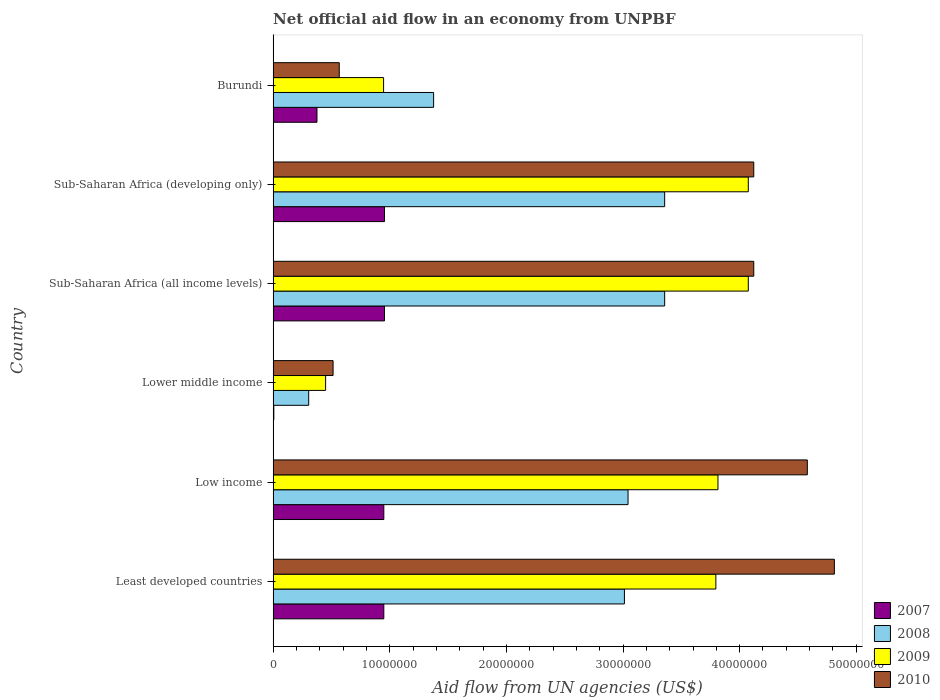How many different coloured bars are there?
Your response must be concise. 4. How many groups of bars are there?
Give a very brief answer. 6. How many bars are there on the 4th tick from the bottom?
Ensure brevity in your answer.  4. What is the net official aid flow in 2007 in Sub-Saharan Africa (developing only)?
Ensure brevity in your answer.  9.55e+06. Across all countries, what is the maximum net official aid flow in 2007?
Offer a very short reply. 9.55e+06. Across all countries, what is the minimum net official aid flow in 2008?
Keep it short and to the point. 3.05e+06. In which country was the net official aid flow in 2010 maximum?
Provide a short and direct response. Least developed countries. In which country was the net official aid flow in 2010 minimum?
Provide a short and direct response. Lower middle income. What is the total net official aid flow in 2008 in the graph?
Provide a succinct answer. 1.44e+08. What is the difference between the net official aid flow in 2007 in Low income and that in Sub-Saharan Africa (developing only)?
Keep it short and to the point. -6.00e+04. What is the difference between the net official aid flow in 2010 in Least developed countries and the net official aid flow in 2007 in Low income?
Your answer should be very brief. 3.86e+07. What is the average net official aid flow in 2009 per country?
Provide a short and direct response. 2.86e+07. What is the difference between the net official aid flow in 2008 and net official aid flow in 2010 in Least developed countries?
Provide a short and direct response. -1.80e+07. In how many countries, is the net official aid flow in 2008 greater than 6000000 US$?
Make the answer very short. 5. What is the ratio of the net official aid flow in 2009 in Least developed countries to that in Low income?
Ensure brevity in your answer.  1. What is the difference between the highest and the second highest net official aid flow in 2010?
Give a very brief answer. 2.32e+06. What is the difference between the highest and the lowest net official aid flow in 2008?
Ensure brevity in your answer.  3.05e+07. Is the sum of the net official aid flow in 2009 in Least developed countries and Sub-Saharan Africa (all income levels) greater than the maximum net official aid flow in 2010 across all countries?
Give a very brief answer. Yes. What does the 3rd bar from the top in Low income represents?
Keep it short and to the point. 2008. How many bars are there?
Give a very brief answer. 24. Are all the bars in the graph horizontal?
Your response must be concise. Yes. What is the difference between two consecutive major ticks on the X-axis?
Offer a terse response. 1.00e+07. How are the legend labels stacked?
Provide a succinct answer. Vertical. What is the title of the graph?
Provide a short and direct response. Net official aid flow in an economy from UNPBF. Does "2015" appear as one of the legend labels in the graph?
Your answer should be compact. No. What is the label or title of the X-axis?
Your answer should be very brief. Aid flow from UN agencies (US$). What is the Aid flow from UN agencies (US$) of 2007 in Least developed countries?
Your answer should be compact. 9.49e+06. What is the Aid flow from UN agencies (US$) of 2008 in Least developed countries?
Your response must be concise. 3.01e+07. What is the Aid flow from UN agencies (US$) of 2009 in Least developed countries?
Make the answer very short. 3.80e+07. What is the Aid flow from UN agencies (US$) in 2010 in Least developed countries?
Your answer should be very brief. 4.81e+07. What is the Aid flow from UN agencies (US$) in 2007 in Low income?
Offer a terse response. 9.49e+06. What is the Aid flow from UN agencies (US$) of 2008 in Low income?
Make the answer very short. 3.04e+07. What is the Aid flow from UN agencies (US$) in 2009 in Low income?
Your answer should be very brief. 3.81e+07. What is the Aid flow from UN agencies (US$) in 2010 in Low income?
Provide a short and direct response. 4.58e+07. What is the Aid flow from UN agencies (US$) of 2007 in Lower middle income?
Your response must be concise. 6.00e+04. What is the Aid flow from UN agencies (US$) in 2008 in Lower middle income?
Your response must be concise. 3.05e+06. What is the Aid flow from UN agencies (US$) of 2009 in Lower middle income?
Your answer should be compact. 4.50e+06. What is the Aid flow from UN agencies (US$) of 2010 in Lower middle income?
Your response must be concise. 5.14e+06. What is the Aid flow from UN agencies (US$) in 2007 in Sub-Saharan Africa (all income levels)?
Keep it short and to the point. 9.55e+06. What is the Aid flow from UN agencies (US$) of 2008 in Sub-Saharan Africa (all income levels)?
Your answer should be compact. 3.36e+07. What is the Aid flow from UN agencies (US$) in 2009 in Sub-Saharan Africa (all income levels)?
Your response must be concise. 4.07e+07. What is the Aid flow from UN agencies (US$) in 2010 in Sub-Saharan Africa (all income levels)?
Your response must be concise. 4.12e+07. What is the Aid flow from UN agencies (US$) in 2007 in Sub-Saharan Africa (developing only)?
Your answer should be compact. 9.55e+06. What is the Aid flow from UN agencies (US$) in 2008 in Sub-Saharan Africa (developing only)?
Provide a succinct answer. 3.36e+07. What is the Aid flow from UN agencies (US$) in 2009 in Sub-Saharan Africa (developing only)?
Offer a terse response. 4.07e+07. What is the Aid flow from UN agencies (US$) in 2010 in Sub-Saharan Africa (developing only)?
Provide a short and direct response. 4.12e+07. What is the Aid flow from UN agencies (US$) of 2007 in Burundi?
Give a very brief answer. 3.76e+06. What is the Aid flow from UN agencies (US$) of 2008 in Burundi?
Keep it short and to the point. 1.38e+07. What is the Aid flow from UN agencies (US$) in 2009 in Burundi?
Keep it short and to the point. 9.47e+06. What is the Aid flow from UN agencies (US$) in 2010 in Burundi?
Offer a terse response. 5.67e+06. Across all countries, what is the maximum Aid flow from UN agencies (US$) of 2007?
Offer a very short reply. 9.55e+06. Across all countries, what is the maximum Aid flow from UN agencies (US$) of 2008?
Give a very brief answer. 3.36e+07. Across all countries, what is the maximum Aid flow from UN agencies (US$) of 2009?
Ensure brevity in your answer.  4.07e+07. Across all countries, what is the maximum Aid flow from UN agencies (US$) in 2010?
Make the answer very short. 4.81e+07. Across all countries, what is the minimum Aid flow from UN agencies (US$) in 2008?
Offer a terse response. 3.05e+06. Across all countries, what is the minimum Aid flow from UN agencies (US$) of 2009?
Provide a succinct answer. 4.50e+06. Across all countries, what is the minimum Aid flow from UN agencies (US$) of 2010?
Make the answer very short. 5.14e+06. What is the total Aid flow from UN agencies (US$) of 2007 in the graph?
Offer a very short reply. 4.19e+07. What is the total Aid flow from UN agencies (US$) of 2008 in the graph?
Give a very brief answer. 1.44e+08. What is the total Aid flow from UN agencies (US$) in 2009 in the graph?
Your response must be concise. 1.72e+08. What is the total Aid flow from UN agencies (US$) in 2010 in the graph?
Offer a terse response. 1.87e+08. What is the difference between the Aid flow from UN agencies (US$) in 2008 in Least developed countries and that in Low income?
Ensure brevity in your answer.  -3.10e+05. What is the difference between the Aid flow from UN agencies (US$) in 2009 in Least developed countries and that in Low income?
Your response must be concise. -1.80e+05. What is the difference between the Aid flow from UN agencies (US$) in 2010 in Least developed countries and that in Low income?
Provide a succinct answer. 2.32e+06. What is the difference between the Aid flow from UN agencies (US$) of 2007 in Least developed countries and that in Lower middle income?
Your answer should be compact. 9.43e+06. What is the difference between the Aid flow from UN agencies (US$) of 2008 in Least developed countries and that in Lower middle income?
Provide a succinct answer. 2.71e+07. What is the difference between the Aid flow from UN agencies (US$) of 2009 in Least developed countries and that in Lower middle income?
Make the answer very short. 3.35e+07. What is the difference between the Aid flow from UN agencies (US$) of 2010 in Least developed countries and that in Lower middle income?
Your response must be concise. 4.30e+07. What is the difference between the Aid flow from UN agencies (US$) in 2008 in Least developed countries and that in Sub-Saharan Africa (all income levels)?
Make the answer very short. -3.45e+06. What is the difference between the Aid flow from UN agencies (US$) in 2009 in Least developed countries and that in Sub-Saharan Africa (all income levels)?
Offer a terse response. -2.78e+06. What is the difference between the Aid flow from UN agencies (US$) of 2010 in Least developed countries and that in Sub-Saharan Africa (all income levels)?
Give a very brief answer. 6.91e+06. What is the difference between the Aid flow from UN agencies (US$) of 2007 in Least developed countries and that in Sub-Saharan Africa (developing only)?
Provide a succinct answer. -6.00e+04. What is the difference between the Aid flow from UN agencies (US$) of 2008 in Least developed countries and that in Sub-Saharan Africa (developing only)?
Offer a terse response. -3.45e+06. What is the difference between the Aid flow from UN agencies (US$) of 2009 in Least developed countries and that in Sub-Saharan Africa (developing only)?
Provide a succinct answer. -2.78e+06. What is the difference between the Aid flow from UN agencies (US$) of 2010 in Least developed countries and that in Sub-Saharan Africa (developing only)?
Provide a succinct answer. 6.91e+06. What is the difference between the Aid flow from UN agencies (US$) in 2007 in Least developed countries and that in Burundi?
Give a very brief answer. 5.73e+06. What is the difference between the Aid flow from UN agencies (US$) in 2008 in Least developed countries and that in Burundi?
Offer a very short reply. 1.64e+07. What is the difference between the Aid flow from UN agencies (US$) in 2009 in Least developed countries and that in Burundi?
Offer a very short reply. 2.85e+07. What is the difference between the Aid flow from UN agencies (US$) in 2010 in Least developed countries and that in Burundi?
Your answer should be compact. 4.24e+07. What is the difference between the Aid flow from UN agencies (US$) in 2007 in Low income and that in Lower middle income?
Your answer should be compact. 9.43e+06. What is the difference between the Aid flow from UN agencies (US$) in 2008 in Low income and that in Lower middle income?
Keep it short and to the point. 2.74e+07. What is the difference between the Aid flow from UN agencies (US$) in 2009 in Low income and that in Lower middle income?
Offer a very short reply. 3.36e+07. What is the difference between the Aid flow from UN agencies (US$) of 2010 in Low income and that in Lower middle income?
Your answer should be very brief. 4.07e+07. What is the difference between the Aid flow from UN agencies (US$) of 2008 in Low income and that in Sub-Saharan Africa (all income levels)?
Your answer should be very brief. -3.14e+06. What is the difference between the Aid flow from UN agencies (US$) of 2009 in Low income and that in Sub-Saharan Africa (all income levels)?
Ensure brevity in your answer.  -2.60e+06. What is the difference between the Aid flow from UN agencies (US$) in 2010 in Low income and that in Sub-Saharan Africa (all income levels)?
Your answer should be very brief. 4.59e+06. What is the difference between the Aid flow from UN agencies (US$) in 2008 in Low income and that in Sub-Saharan Africa (developing only)?
Provide a succinct answer. -3.14e+06. What is the difference between the Aid flow from UN agencies (US$) in 2009 in Low income and that in Sub-Saharan Africa (developing only)?
Make the answer very short. -2.60e+06. What is the difference between the Aid flow from UN agencies (US$) in 2010 in Low income and that in Sub-Saharan Africa (developing only)?
Your response must be concise. 4.59e+06. What is the difference between the Aid flow from UN agencies (US$) in 2007 in Low income and that in Burundi?
Provide a short and direct response. 5.73e+06. What is the difference between the Aid flow from UN agencies (US$) in 2008 in Low income and that in Burundi?
Your answer should be compact. 1.67e+07. What is the difference between the Aid flow from UN agencies (US$) of 2009 in Low income and that in Burundi?
Keep it short and to the point. 2.87e+07. What is the difference between the Aid flow from UN agencies (US$) of 2010 in Low income and that in Burundi?
Your answer should be compact. 4.01e+07. What is the difference between the Aid flow from UN agencies (US$) in 2007 in Lower middle income and that in Sub-Saharan Africa (all income levels)?
Ensure brevity in your answer.  -9.49e+06. What is the difference between the Aid flow from UN agencies (US$) of 2008 in Lower middle income and that in Sub-Saharan Africa (all income levels)?
Offer a very short reply. -3.05e+07. What is the difference between the Aid flow from UN agencies (US$) of 2009 in Lower middle income and that in Sub-Saharan Africa (all income levels)?
Provide a succinct answer. -3.62e+07. What is the difference between the Aid flow from UN agencies (US$) of 2010 in Lower middle income and that in Sub-Saharan Africa (all income levels)?
Ensure brevity in your answer.  -3.61e+07. What is the difference between the Aid flow from UN agencies (US$) in 2007 in Lower middle income and that in Sub-Saharan Africa (developing only)?
Provide a succinct answer. -9.49e+06. What is the difference between the Aid flow from UN agencies (US$) in 2008 in Lower middle income and that in Sub-Saharan Africa (developing only)?
Your answer should be compact. -3.05e+07. What is the difference between the Aid flow from UN agencies (US$) in 2009 in Lower middle income and that in Sub-Saharan Africa (developing only)?
Offer a very short reply. -3.62e+07. What is the difference between the Aid flow from UN agencies (US$) in 2010 in Lower middle income and that in Sub-Saharan Africa (developing only)?
Offer a very short reply. -3.61e+07. What is the difference between the Aid flow from UN agencies (US$) in 2007 in Lower middle income and that in Burundi?
Make the answer very short. -3.70e+06. What is the difference between the Aid flow from UN agencies (US$) in 2008 in Lower middle income and that in Burundi?
Ensure brevity in your answer.  -1.07e+07. What is the difference between the Aid flow from UN agencies (US$) of 2009 in Lower middle income and that in Burundi?
Your answer should be very brief. -4.97e+06. What is the difference between the Aid flow from UN agencies (US$) in 2010 in Lower middle income and that in Burundi?
Keep it short and to the point. -5.30e+05. What is the difference between the Aid flow from UN agencies (US$) in 2007 in Sub-Saharan Africa (all income levels) and that in Sub-Saharan Africa (developing only)?
Provide a short and direct response. 0. What is the difference between the Aid flow from UN agencies (US$) in 2008 in Sub-Saharan Africa (all income levels) and that in Sub-Saharan Africa (developing only)?
Offer a terse response. 0. What is the difference between the Aid flow from UN agencies (US$) of 2007 in Sub-Saharan Africa (all income levels) and that in Burundi?
Provide a succinct answer. 5.79e+06. What is the difference between the Aid flow from UN agencies (US$) of 2008 in Sub-Saharan Africa (all income levels) and that in Burundi?
Your answer should be very brief. 1.98e+07. What is the difference between the Aid flow from UN agencies (US$) of 2009 in Sub-Saharan Africa (all income levels) and that in Burundi?
Offer a terse response. 3.13e+07. What is the difference between the Aid flow from UN agencies (US$) of 2010 in Sub-Saharan Africa (all income levels) and that in Burundi?
Your answer should be compact. 3.55e+07. What is the difference between the Aid flow from UN agencies (US$) of 2007 in Sub-Saharan Africa (developing only) and that in Burundi?
Make the answer very short. 5.79e+06. What is the difference between the Aid flow from UN agencies (US$) of 2008 in Sub-Saharan Africa (developing only) and that in Burundi?
Keep it short and to the point. 1.98e+07. What is the difference between the Aid flow from UN agencies (US$) in 2009 in Sub-Saharan Africa (developing only) and that in Burundi?
Provide a short and direct response. 3.13e+07. What is the difference between the Aid flow from UN agencies (US$) of 2010 in Sub-Saharan Africa (developing only) and that in Burundi?
Offer a terse response. 3.55e+07. What is the difference between the Aid flow from UN agencies (US$) in 2007 in Least developed countries and the Aid flow from UN agencies (US$) in 2008 in Low income?
Provide a short and direct response. -2.09e+07. What is the difference between the Aid flow from UN agencies (US$) of 2007 in Least developed countries and the Aid flow from UN agencies (US$) of 2009 in Low income?
Your response must be concise. -2.86e+07. What is the difference between the Aid flow from UN agencies (US$) in 2007 in Least developed countries and the Aid flow from UN agencies (US$) in 2010 in Low income?
Make the answer very short. -3.63e+07. What is the difference between the Aid flow from UN agencies (US$) of 2008 in Least developed countries and the Aid flow from UN agencies (US$) of 2009 in Low income?
Offer a very short reply. -8.02e+06. What is the difference between the Aid flow from UN agencies (US$) of 2008 in Least developed countries and the Aid flow from UN agencies (US$) of 2010 in Low income?
Ensure brevity in your answer.  -1.57e+07. What is the difference between the Aid flow from UN agencies (US$) of 2009 in Least developed countries and the Aid flow from UN agencies (US$) of 2010 in Low income?
Provide a succinct answer. -7.84e+06. What is the difference between the Aid flow from UN agencies (US$) in 2007 in Least developed countries and the Aid flow from UN agencies (US$) in 2008 in Lower middle income?
Offer a very short reply. 6.44e+06. What is the difference between the Aid flow from UN agencies (US$) in 2007 in Least developed countries and the Aid flow from UN agencies (US$) in 2009 in Lower middle income?
Ensure brevity in your answer.  4.99e+06. What is the difference between the Aid flow from UN agencies (US$) of 2007 in Least developed countries and the Aid flow from UN agencies (US$) of 2010 in Lower middle income?
Offer a terse response. 4.35e+06. What is the difference between the Aid flow from UN agencies (US$) of 2008 in Least developed countries and the Aid flow from UN agencies (US$) of 2009 in Lower middle income?
Give a very brief answer. 2.56e+07. What is the difference between the Aid flow from UN agencies (US$) of 2008 in Least developed countries and the Aid flow from UN agencies (US$) of 2010 in Lower middle income?
Your response must be concise. 2.50e+07. What is the difference between the Aid flow from UN agencies (US$) of 2009 in Least developed countries and the Aid flow from UN agencies (US$) of 2010 in Lower middle income?
Provide a short and direct response. 3.28e+07. What is the difference between the Aid flow from UN agencies (US$) of 2007 in Least developed countries and the Aid flow from UN agencies (US$) of 2008 in Sub-Saharan Africa (all income levels)?
Provide a short and direct response. -2.41e+07. What is the difference between the Aid flow from UN agencies (US$) of 2007 in Least developed countries and the Aid flow from UN agencies (US$) of 2009 in Sub-Saharan Africa (all income levels)?
Keep it short and to the point. -3.12e+07. What is the difference between the Aid flow from UN agencies (US$) of 2007 in Least developed countries and the Aid flow from UN agencies (US$) of 2010 in Sub-Saharan Africa (all income levels)?
Your answer should be very brief. -3.17e+07. What is the difference between the Aid flow from UN agencies (US$) in 2008 in Least developed countries and the Aid flow from UN agencies (US$) in 2009 in Sub-Saharan Africa (all income levels)?
Your answer should be very brief. -1.06e+07. What is the difference between the Aid flow from UN agencies (US$) in 2008 in Least developed countries and the Aid flow from UN agencies (US$) in 2010 in Sub-Saharan Africa (all income levels)?
Your answer should be very brief. -1.11e+07. What is the difference between the Aid flow from UN agencies (US$) in 2009 in Least developed countries and the Aid flow from UN agencies (US$) in 2010 in Sub-Saharan Africa (all income levels)?
Provide a succinct answer. -3.25e+06. What is the difference between the Aid flow from UN agencies (US$) in 2007 in Least developed countries and the Aid flow from UN agencies (US$) in 2008 in Sub-Saharan Africa (developing only)?
Offer a very short reply. -2.41e+07. What is the difference between the Aid flow from UN agencies (US$) of 2007 in Least developed countries and the Aid flow from UN agencies (US$) of 2009 in Sub-Saharan Africa (developing only)?
Make the answer very short. -3.12e+07. What is the difference between the Aid flow from UN agencies (US$) in 2007 in Least developed countries and the Aid flow from UN agencies (US$) in 2010 in Sub-Saharan Africa (developing only)?
Offer a terse response. -3.17e+07. What is the difference between the Aid flow from UN agencies (US$) of 2008 in Least developed countries and the Aid flow from UN agencies (US$) of 2009 in Sub-Saharan Africa (developing only)?
Provide a succinct answer. -1.06e+07. What is the difference between the Aid flow from UN agencies (US$) in 2008 in Least developed countries and the Aid flow from UN agencies (US$) in 2010 in Sub-Saharan Africa (developing only)?
Provide a succinct answer. -1.11e+07. What is the difference between the Aid flow from UN agencies (US$) of 2009 in Least developed countries and the Aid flow from UN agencies (US$) of 2010 in Sub-Saharan Africa (developing only)?
Ensure brevity in your answer.  -3.25e+06. What is the difference between the Aid flow from UN agencies (US$) of 2007 in Least developed countries and the Aid flow from UN agencies (US$) of 2008 in Burundi?
Give a very brief answer. -4.27e+06. What is the difference between the Aid flow from UN agencies (US$) of 2007 in Least developed countries and the Aid flow from UN agencies (US$) of 2009 in Burundi?
Provide a succinct answer. 2.00e+04. What is the difference between the Aid flow from UN agencies (US$) in 2007 in Least developed countries and the Aid flow from UN agencies (US$) in 2010 in Burundi?
Give a very brief answer. 3.82e+06. What is the difference between the Aid flow from UN agencies (US$) in 2008 in Least developed countries and the Aid flow from UN agencies (US$) in 2009 in Burundi?
Ensure brevity in your answer.  2.06e+07. What is the difference between the Aid flow from UN agencies (US$) in 2008 in Least developed countries and the Aid flow from UN agencies (US$) in 2010 in Burundi?
Offer a very short reply. 2.44e+07. What is the difference between the Aid flow from UN agencies (US$) in 2009 in Least developed countries and the Aid flow from UN agencies (US$) in 2010 in Burundi?
Your response must be concise. 3.23e+07. What is the difference between the Aid flow from UN agencies (US$) in 2007 in Low income and the Aid flow from UN agencies (US$) in 2008 in Lower middle income?
Provide a short and direct response. 6.44e+06. What is the difference between the Aid flow from UN agencies (US$) in 2007 in Low income and the Aid flow from UN agencies (US$) in 2009 in Lower middle income?
Your response must be concise. 4.99e+06. What is the difference between the Aid flow from UN agencies (US$) of 2007 in Low income and the Aid flow from UN agencies (US$) of 2010 in Lower middle income?
Offer a very short reply. 4.35e+06. What is the difference between the Aid flow from UN agencies (US$) of 2008 in Low income and the Aid flow from UN agencies (US$) of 2009 in Lower middle income?
Provide a succinct answer. 2.59e+07. What is the difference between the Aid flow from UN agencies (US$) in 2008 in Low income and the Aid flow from UN agencies (US$) in 2010 in Lower middle income?
Keep it short and to the point. 2.53e+07. What is the difference between the Aid flow from UN agencies (US$) of 2009 in Low income and the Aid flow from UN agencies (US$) of 2010 in Lower middle income?
Your response must be concise. 3.30e+07. What is the difference between the Aid flow from UN agencies (US$) in 2007 in Low income and the Aid flow from UN agencies (US$) in 2008 in Sub-Saharan Africa (all income levels)?
Provide a succinct answer. -2.41e+07. What is the difference between the Aid flow from UN agencies (US$) in 2007 in Low income and the Aid flow from UN agencies (US$) in 2009 in Sub-Saharan Africa (all income levels)?
Make the answer very short. -3.12e+07. What is the difference between the Aid flow from UN agencies (US$) of 2007 in Low income and the Aid flow from UN agencies (US$) of 2010 in Sub-Saharan Africa (all income levels)?
Offer a very short reply. -3.17e+07. What is the difference between the Aid flow from UN agencies (US$) in 2008 in Low income and the Aid flow from UN agencies (US$) in 2009 in Sub-Saharan Africa (all income levels)?
Ensure brevity in your answer.  -1.03e+07. What is the difference between the Aid flow from UN agencies (US$) of 2008 in Low income and the Aid flow from UN agencies (US$) of 2010 in Sub-Saharan Africa (all income levels)?
Offer a very short reply. -1.08e+07. What is the difference between the Aid flow from UN agencies (US$) of 2009 in Low income and the Aid flow from UN agencies (US$) of 2010 in Sub-Saharan Africa (all income levels)?
Your response must be concise. -3.07e+06. What is the difference between the Aid flow from UN agencies (US$) of 2007 in Low income and the Aid flow from UN agencies (US$) of 2008 in Sub-Saharan Africa (developing only)?
Keep it short and to the point. -2.41e+07. What is the difference between the Aid flow from UN agencies (US$) of 2007 in Low income and the Aid flow from UN agencies (US$) of 2009 in Sub-Saharan Africa (developing only)?
Keep it short and to the point. -3.12e+07. What is the difference between the Aid flow from UN agencies (US$) in 2007 in Low income and the Aid flow from UN agencies (US$) in 2010 in Sub-Saharan Africa (developing only)?
Your response must be concise. -3.17e+07. What is the difference between the Aid flow from UN agencies (US$) in 2008 in Low income and the Aid flow from UN agencies (US$) in 2009 in Sub-Saharan Africa (developing only)?
Give a very brief answer. -1.03e+07. What is the difference between the Aid flow from UN agencies (US$) of 2008 in Low income and the Aid flow from UN agencies (US$) of 2010 in Sub-Saharan Africa (developing only)?
Keep it short and to the point. -1.08e+07. What is the difference between the Aid flow from UN agencies (US$) of 2009 in Low income and the Aid flow from UN agencies (US$) of 2010 in Sub-Saharan Africa (developing only)?
Keep it short and to the point. -3.07e+06. What is the difference between the Aid flow from UN agencies (US$) in 2007 in Low income and the Aid flow from UN agencies (US$) in 2008 in Burundi?
Give a very brief answer. -4.27e+06. What is the difference between the Aid flow from UN agencies (US$) of 2007 in Low income and the Aid flow from UN agencies (US$) of 2010 in Burundi?
Offer a very short reply. 3.82e+06. What is the difference between the Aid flow from UN agencies (US$) in 2008 in Low income and the Aid flow from UN agencies (US$) in 2009 in Burundi?
Your answer should be compact. 2.10e+07. What is the difference between the Aid flow from UN agencies (US$) of 2008 in Low income and the Aid flow from UN agencies (US$) of 2010 in Burundi?
Your answer should be very brief. 2.48e+07. What is the difference between the Aid flow from UN agencies (US$) in 2009 in Low income and the Aid flow from UN agencies (US$) in 2010 in Burundi?
Provide a succinct answer. 3.25e+07. What is the difference between the Aid flow from UN agencies (US$) in 2007 in Lower middle income and the Aid flow from UN agencies (US$) in 2008 in Sub-Saharan Africa (all income levels)?
Your response must be concise. -3.35e+07. What is the difference between the Aid flow from UN agencies (US$) of 2007 in Lower middle income and the Aid flow from UN agencies (US$) of 2009 in Sub-Saharan Africa (all income levels)?
Your answer should be compact. -4.07e+07. What is the difference between the Aid flow from UN agencies (US$) in 2007 in Lower middle income and the Aid flow from UN agencies (US$) in 2010 in Sub-Saharan Africa (all income levels)?
Your response must be concise. -4.12e+07. What is the difference between the Aid flow from UN agencies (US$) of 2008 in Lower middle income and the Aid flow from UN agencies (US$) of 2009 in Sub-Saharan Africa (all income levels)?
Give a very brief answer. -3.77e+07. What is the difference between the Aid flow from UN agencies (US$) in 2008 in Lower middle income and the Aid flow from UN agencies (US$) in 2010 in Sub-Saharan Africa (all income levels)?
Offer a terse response. -3.82e+07. What is the difference between the Aid flow from UN agencies (US$) of 2009 in Lower middle income and the Aid flow from UN agencies (US$) of 2010 in Sub-Saharan Africa (all income levels)?
Your answer should be compact. -3.67e+07. What is the difference between the Aid flow from UN agencies (US$) of 2007 in Lower middle income and the Aid flow from UN agencies (US$) of 2008 in Sub-Saharan Africa (developing only)?
Your answer should be very brief. -3.35e+07. What is the difference between the Aid flow from UN agencies (US$) of 2007 in Lower middle income and the Aid flow from UN agencies (US$) of 2009 in Sub-Saharan Africa (developing only)?
Keep it short and to the point. -4.07e+07. What is the difference between the Aid flow from UN agencies (US$) in 2007 in Lower middle income and the Aid flow from UN agencies (US$) in 2010 in Sub-Saharan Africa (developing only)?
Ensure brevity in your answer.  -4.12e+07. What is the difference between the Aid flow from UN agencies (US$) of 2008 in Lower middle income and the Aid flow from UN agencies (US$) of 2009 in Sub-Saharan Africa (developing only)?
Keep it short and to the point. -3.77e+07. What is the difference between the Aid flow from UN agencies (US$) in 2008 in Lower middle income and the Aid flow from UN agencies (US$) in 2010 in Sub-Saharan Africa (developing only)?
Keep it short and to the point. -3.82e+07. What is the difference between the Aid flow from UN agencies (US$) of 2009 in Lower middle income and the Aid flow from UN agencies (US$) of 2010 in Sub-Saharan Africa (developing only)?
Your answer should be very brief. -3.67e+07. What is the difference between the Aid flow from UN agencies (US$) of 2007 in Lower middle income and the Aid flow from UN agencies (US$) of 2008 in Burundi?
Keep it short and to the point. -1.37e+07. What is the difference between the Aid flow from UN agencies (US$) of 2007 in Lower middle income and the Aid flow from UN agencies (US$) of 2009 in Burundi?
Keep it short and to the point. -9.41e+06. What is the difference between the Aid flow from UN agencies (US$) in 2007 in Lower middle income and the Aid flow from UN agencies (US$) in 2010 in Burundi?
Your answer should be compact. -5.61e+06. What is the difference between the Aid flow from UN agencies (US$) of 2008 in Lower middle income and the Aid flow from UN agencies (US$) of 2009 in Burundi?
Your response must be concise. -6.42e+06. What is the difference between the Aid flow from UN agencies (US$) in 2008 in Lower middle income and the Aid flow from UN agencies (US$) in 2010 in Burundi?
Give a very brief answer. -2.62e+06. What is the difference between the Aid flow from UN agencies (US$) of 2009 in Lower middle income and the Aid flow from UN agencies (US$) of 2010 in Burundi?
Provide a short and direct response. -1.17e+06. What is the difference between the Aid flow from UN agencies (US$) of 2007 in Sub-Saharan Africa (all income levels) and the Aid flow from UN agencies (US$) of 2008 in Sub-Saharan Africa (developing only)?
Give a very brief answer. -2.40e+07. What is the difference between the Aid flow from UN agencies (US$) of 2007 in Sub-Saharan Africa (all income levels) and the Aid flow from UN agencies (US$) of 2009 in Sub-Saharan Africa (developing only)?
Your answer should be compact. -3.12e+07. What is the difference between the Aid flow from UN agencies (US$) of 2007 in Sub-Saharan Africa (all income levels) and the Aid flow from UN agencies (US$) of 2010 in Sub-Saharan Africa (developing only)?
Offer a very short reply. -3.17e+07. What is the difference between the Aid flow from UN agencies (US$) in 2008 in Sub-Saharan Africa (all income levels) and the Aid flow from UN agencies (US$) in 2009 in Sub-Saharan Africa (developing only)?
Offer a terse response. -7.17e+06. What is the difference between the Aid flow from UN agencies (US$) of 2008 in Sub-Saharan Africa (all income levels) and the Aid flow from UN agencies (US$) of 2010 in Sub-Saharan Africa (developing only)?
Make the answer very short. -7.64e+06. What is the difference between the Aid flow from UN agencies (US$) of 2009 in Sub-Saharan Africa (all income levels) and the Aid flow from UN agencies (US$) of 2010 in Sub-Saharan Africa (developing only)?
Give a very brief answer. -4.70e+05. What is the difference between the Aid flow from UN agencies (US$) in 2007 in Sub-Saharan Africa (all income levels) and the Aid flow from UN agencies (US$) in 2008 in Burundi?
Give a very brief answer. -4.21e+06. What is the difference between the Aid flow from UN agencies (US$) in 2007 in Sub-Saharan Africa (all income levels) and the Aid flow from UN agencies (US$) in 2009 in Burundi?
Provide a succinct answer. 8.00e+04. What is the difference between the Aid flow from UN agencies (US$) in 2007 in Sub-Saharan Africa (all income levels) and the Aid flow from UN agencies (US$) in 2010 in Burundi?
Your answer should be very brief. 3.88e+06. What is the difference between the Aid flow from UN agencies (US$) of 2008 in Sub-Saharan Africa (all income levels) and the Aid flow from UN agencies (US$) of 2009 in Burundi?
Ensure brevity in your answer.  2.41e+07. What is the difference between the Aid flow from UN agencies (US$) of 2008 in Sub-Saharan Africa (all income levels) and the Aid flow from UN agencies (US$) of 2010 in Burundi?
Offer a very short reply. 2.79e+07. What is the difference between the Aid flow from UN agencies (US$) in 2009 in Sub-Saharan Africa (all income levels) and the Aid flow from UN agencies (US$) in 2010 in Burundi?
Your response must be concise. 3.51e+07. What is the difference between the Aid flow from UN agencies (US$) of 2007 in Sub-Saharan Africa (developing only) and the Aid flow from UN agencies (US$) of 2008 in Burundi?
Keep it short and to the point. -4.21e+06. What is the difference between the Aid flow from UN agencies (US$) in 2007 in Sub-Saharan Africa (developing only) and the Aid flow from UN agencies (US$) in 2009 in Burundi?
Keep it short and to the point. 8.00e+04. What is the difference between the Aid flow from UN agencies (US$) in 2007 in Sub-Saharan Africa (developing only) and the Aid flow from UN agencies (US$) in 2010 in Burundi?
Your response must be concise. 3.88e+06. What is the difference between the Aid flow from UN agencies (US$) in 2008 in Sub-Saharan Africa (developing only) and the Aid flow from UN agencies (US$) in 2009 in Burundi?
Offer a terse response. 2.41e+07. What is the difference between the Aid flow from UN agencies (US$) of 2008 in Sub-Saharan Africa (developing only) and the Aid flow from UN agencies (US$) of 2010 in Burundi?
Your response must be concise. 2.79e+07. What is the difference between the Aid flow from UN agencies (US$) of 2009 in Sub-Saharan Africa (developing only) and the Aid flow from UN agencies (US$) of 2010 in Burundi?
Make the answer very short. 3.51e+07. What is the average Aid flow from UN agencies (US$) of 2007 per country?
Your response must be concise. 6.98e+06. What is the average Aid flow from UN agencies (US$) of 2008 per country?
Give a very brief answer. 2.41e+07. What is the average Aid flow from UN agencies (US$) of 2009 per country?
Your answer should be compact. 2.86e+07. What is the average Aid flow from UN agencies (US$) in 2010 per country?
Provide a short and direct response. 3.12e+07. What is the difference between the Aid flow from UN agencies (US$) in 2007 and Aid flow from UN agencies (US$) in 2008 in Least developed countries?
Your response must be concise. -2.06e+07. What is the difference between the Aid flow from UN agencies (US$) of 2007 and Aid flow from UN agencies (US$) of 2009 in Least developed countries?
Your answer should be compact. -2.85e+07. What is the difference between the Aid flow from UN agencies (US$) of 2007 and Aid flow from UN agencies (US$) of 2010 in Least developed countries?
Offer a very short reply. -3.86e+07. What is the difference between the Aid flow from UN agencies (US$) in 2008 and Aid flow from UN agencies (US$) in 2009 in Least developed countries?
Your answer should be very brief. -7.84e+06. What is the difference between the Aid flow from UN agencies (US$) in 2008 and Aid flow from UN agencies (US$) in 2010 in Least developed countries?
Keep it short and to the point. -1.80e+07. What is the difference between the Aid flow from UN agencies (US$) in 2009 and Aid flow from UN agencies (US$) in 2010 in Least developed countries?
Your answer should be very brief. -1.02e+07. What is the difference between the Aid flow from UN agencies (US$) of 2007 and Aid flow from UN agencies (US$) of 2008 in Low income?
Your response must be concise. -2.09e+07. What is the difference between the Aid flow from UN agencies (US$) in 2007 and Aid flow from UN agencies (US$) in 2009 in Low income?
Offer a terse response. -2.86e+07. What is the difference between the Aid flow from UN agencies (US$) in 2007 and Aid flow from UN agencies (US$) in 2010 in Low income?
Provide a short and direct response. -3.63e+07. What is the difference between the Aid flow from UN agencies (US$) in 2008 and Aid flow from UN agencies (US$) in 2009 in Low income?
Your answer should be very brief. -7.71e+06. What is the difference between the Aid flow from UN agencies (US$) of 2008 and Aid flow from UN agencies (US$) of 2010 in Low income?
Offer a very short reply. -1.54e+07. What is the difference between the Aid flow from UN agencies (US$) of 2009 and Aid flow from UN agencies (US$) of 2010 in Low income?
Provide a succinct answer. -7.66e+06. What is the difference between the Aid flow from UN agencies (US$) of 2007 and Aid flow from UN agencies (US$) of 2008 in Lower middle income?
Your response must be concise. -2.99e+06. What is the difference between the Aid flow from UN agencies (US$) in 2007 and Aid flow from UN agencies (US$) in 2009 in Lower middle income?
Offer a very short reply. -4.44e+06. What is the difference between the Aid flow from UN agencies (US$) of 2007 and Aid flow from UN agencies (US$) of 2010 in Lower middle income?
Provide a succinct answer. -5.08e+06. What is the difference between the Aid flow from UN agencies (US$) of 2008 and Aid flow from UN agencies (US$) of 2009 in Lower middle income?
Keep it short and to the point. -1.45e+06. What is the difference between the Aid flow from UN agencies (US$) in 2008 and Aid flow from UN agencies (US$) in 2010 in Lower middle income?
Ensure brevity in your answer.  -2.09e+06. What is the difference between the Aid flow from UN agencies (US$) of 2009 and Aid flow from UN agencies (US$) of 2010 in Lower middle income?
Your response must be concise. -6.40e+05. What is the difference between the Aid flow from UN agencies (US$) of 2007 and Aid flow from UN agencies (US$) of 2008 in Sub-Saharan Africa (all income levels)?
Keep it short and to the point. -2.40e+07. What is the difference between the Aid flow from UN agencies (US$) of 2007 and Aid flow from UN agencies (US$) of 2009 in Sub-Saharan Africa (all income levels)?
Offer a very short reply. -3.12e+07. What is the difference between the Aid flow from UN agencies (US$) in 2007 and Aid flow from UN agencies (US$) in 2010 in Sub-Saharan Africa (all income levels)?
Make the answer very short. -3.17e+07. What is the difference between the Aid flow from UN agencies (US$) in 2008 and Aid flow from UN agencies (US$) in 2009 in Sub-Saharan Africa (all income levels)?
Your answer should be very brief. -7.17e+06. What is the difference between the Aid flow from UN agencies (US$) in 2008 and Aid flow from UN agencies (US$) in 2010 in Sub-Saharan Africa (all income levels)?
Keep it short and to the point. -7.64e+06. What is the difference between the Aid flow from UN agencies (US$) of 2009 and Aid flow from UN agencies (US$) of 2010 in Sub-Saharan Africa (all income levels)?
Give a very brief answer. -4.70e+05. What is the difference between the Aid flow from UN agencies (US$) of 2007 and Aid flow from UN agencies (US$) of 2008 in Sub-Saharan Africa (developing only)?
Your answer should be compact. -2.40e+07. What is the difference between the Aid flow from UN agencies (US$) in 2007 and Aid flow from UN agencies (US$) in 2009 in Sub-Saharan Africa (developing only)?
Make the answer very short. -3.12e+07. What is the difference between the Aid flow from UN agencies (US$) of 2007 and Aid flow from UN agencies (US$) of 2010 in Sub-Saharan Africa (developing only)?
Make the answer very short. -3.17e+07. What is the difference between the Aid flow from UN agencies (US$) of 2008 and Aid flow from UN agencies (US$) of 2009 in Sub-Saharan Africa (developing only)?
Ensure brevity in your answer.  -7.17e+06. What is the difference between the Aid flow from UN agencies (US$) of 2008 and Aid flow from UN agencies (US$) of 2010 in Sub-Saharan Africa (developing only)?
Make the answer very short. -7.64e+06. What is the difference between the Aid flow from UN agencies (US$) of 2009 and Aid flow from UN agencies (US$) of 2010 in Sub-Saharan Africa (developing only)?
Provide a short and direct response. -4.70e+05. What is the difference between the Aid flow from UN agencies (US$) of 2007 and Aid flow from UN agencies (US$) of 2008 in Burundi?
Provide a short and direct response. -1.00e+07. What is the difference between the Aid flow from UN agencies (US$) of 2007 and Aid flow from UN agencies (US$) of 2009 in Burundi?
Give a very brief answer. -5.71e+06. What is the difference between the Aid flow from UN agencies (US$) of 2007 and Aid flow from UN agencies (US$) of 2010 in Burundi?
Your answer should be very brief. -1.91e+06. What is the difference between the Aid flow from UN agencies (US$) in 2008 and Aid flow from UN agencies (US$) in 2009 in Burundi?
Your answer should be very brief. 4.29e+06. What is the difference between the Aid flow from UN agencies (US$) in 2008 and Aid flow from UN agencies (US$) in 2010 in Burundi?
Provide a succinct answer. 8.09e+06. What is the difference between the Aid flow from UN agencies (US$) in 2009 and Aid flow from UN agencies (US$) in 2010 in Burundi?
Your answer should be very brief. 3.80e+06. What is the ratio of the Aid flow from UN agencies (US$) in 2010 in Least developed countries to that in Low income?
Give a very brief answer. 1.05. What is the ratio of the Aid flow from UN agencies (US$) of 2007 in Least developed countries to that in Lower middle income?
Provide a short and direct response. 158.17. What is the ratio of the Aid flow from UN agencies (US$) of 2008 in Least developed countries to that in Lower middle income?
Give a very brief answer. 9.88. What is the ratio of the Aid flow from UN agencies (US$) in 2009 in Least developed countries to that in Lower middle income?
Make the answer very short. 8.44. What is the ratio of the Aid flow from UN agencies (US$) of 2010 in Least developed countries to that in Lower middle income?
Offer a very short reply. 9.36. What is the ratio of the Aid flow from UN agencies (US$) in 2008 in Least developed countries to that in Sub-Saharan Africa (all income levels)?
Make the answer very short. 0.9. What is the ratio of the Aid flow from UN agencies (US$) in 2009 in Least developed countries to that in Sub-Saharan Africa (all income levels)?
Your answer should be very brief. 0.93. What is the ratio of the Aid flow from UN agencies (US$) in 2010 in Least developed countries to that in Sub-Saharan Africa (all income levels)?
Your answer should be very brief. 1.17. What is the ratio of the Aid flow from UN agencies (US$) in 2008 in Least developed countries to that in Sub-Saharan Africa (developing only)?
Make the answer very short. 0.9. What is the ratio of the Aid flow from UN agencies (US$) of 2009 in Least developed countries to that in Sub-Saharan Africa (developing only)?
Your answer should be compact. 0.93. What is the ratio of the Aid flow from UN agencies (US$) of 2010 in Least developed countries to that in Sub-Saharan Africa (developing only)?
Provide a succinct answer. 1.17. What is the ratio of the Aid flow from UN agencies (US$) in 2007 in Least developed countries to that in Burundi?
Your answer should be very brief. 2.52. What is the ratio of the Aid flow from UN agencies (US$) in 2008 in Least developed countries to that in Burundi?
Offer a terse response. 2.19. What is the ratio of the Aid flow from UN agencies (US$) of 2009 in Least developed countries to that in Burundi?
Offer a terse response. 4.01. What is the ratio of the Aid flow from UN agencies (US$) of 2010 in Least developed countries to that in Burundi?
Give a very brief answer. 8.49. What is the ratio of the Aid flow from UN agencies (US$) in 2007 in Low income to that in Lower middle income?
Ensure brevity in your answer.  158.17. What is the ratio of the Aid flow from UN agencies (US$) in 2008 in Low income to that in Lower middle income?
Your response must be concise. 9.98. What is the ratio of the Aid flow from UN agencies (US$) of 2009 in Low income to that in Lower middle income?
Provide a succinct answer. 8.48. What is the ratio of the Aid flow from UN agencies (US$) in 2010 in Low income to that in Lower middle income?
Your response must be concise. 8.91. What is the ratio of the Aid flow from UN agencies (US$) in 2008 in Low income to that in Sub-Saharan Africa (all income levels)?
Ensure brevity in your answer.  0.91. What is the ratio of the Aid flow from UN agencies (US$) of 2009 in Low income to that in Sub-Saharan Africa (all income levels)?
Keep it short and to the point. 0.94. What is the ratio of the Aid flow from UN agencies (US$) in 2010 in Low income to that in Sub-Saharan Africa (all income levels)?
Provide a short and direct response. 1.11. What is the ratio of the Aid flow from UN agencies (US$) of 2008 in Low income to that in Sub-Saharan Africa (developing only)?
Your response must be concise. 0.91. What is the ratio of the Aid flow from UN agencies (US$) of 2009 in Low income to that in Sub-Saharan Africa (developing only)?
Provide a short and direct response. 0.94. What is the ratio of the Aid flow from UN agencies (US$) in 2010 in Low income to that in Sub-Saharan Africa (developing only)?
Provide a succinct answer. 1.11. What is the ratio of the Aid flow from UN agencies (US$) in 2007 in Low income to that in Burundi?
Provide a succinct answer. 2.52. What is the ratio of the Aid flow from UN agencies (US$) of 2008 in Low income to that in Burundi?
Provide a succinct answer. 2.21. What is the ratio of the Aid flow from UN agencies (US$) in 2009 in Low income to that in Burundi?
Keep it short and to the point. 4.03. What is the ratio of the Aid flow from UN agencies (US$) in 2010 in Low income to that in Burundi?
Offer a very short reply. 8.08. What is the ratio of the Aid flow from UN agencies (US$) in 2007 in Lower middle income to that in Sub-Saharan Africa (all income levels)?
Offer a very short reply. 0.01. What is the ratio of the Aid flow from UN agencies (US$) of 2008 in Lower middle income to that in Sub-Saharan Africa (all income levels)?
Your answer should be compact. 0.09. What is the ratio of the Aid flow from UN agencies (US$) in 2009 in Lower middle income to that in Sub-Saharan Africa (all income levels)?
Keep it short and to the point. 0.11. What is the ratio of the Aid flow from UN agencies (US$) in 2010 in Lower middle income to that in Sub-Saharan Africa (all income levels)?
Provide a succinct answer. 0.12. What is the ratio of the Aid flow from UN agencies (US$) in 2007 in Lower middle income to that in Sub-Saharan Africa (developing only)?
Your answer should be very brief. 0.01. What is the ratio of the Aid flow from UN agencies (US$) of 2008 in Lower middle income to that in Sub-Saharan Africa (developing only)?
Make the answer very short. 0.09. What is the ratio of the Aid flow from UN agencies (US$) in 2009 in Lower middle income to that in Sub-Saharan Africa (developing only)?
Make the answer very short. 0.11. What is the ratio of the Aid flow from UN agencies (US$) of 2010 in Lower middle income to that in Sub-Saharan Africa (developing only)?
Your answer should be very brief. 0.12. What is the ratio of the Aid flow from UN agencies (US$) in 2007 in Lower middle income to that in Burundi?
Give a very brief answer. 0.02. What is the ratio of the Aid flow from UN agencies (US$) of 2008 in Lower middle income to that in Burundi?
Your answer should be compact. 0.22. What is the ratio of the Aid flow from UN agencies (US$) of 2009 in Lower middle income to that in Burundi?
Provide a short and direct response. 0.48. What is the ratio of the Aid flow from UN agencies (US$) of 2010 in Lower middle income to that in Burundi?
Your response must be concise. 0.91. What is the ratio of the Aid flow from UN agencies (US$) in 2007 in Sub-Saharan Africa (all income levels) to that in Burundi?
Provide a succinct answer. 2.54. What is the ratio of the Aid flow from UN agencies (US$) of 2008 in Sub-Saharan Africa (all income levels) to that in Burundi?
Give a very brief answer. 2.44. What is the ratio of the Aid flow from UN agencies (US$) of 2009 in Sub-Saharan Africa (all income levels) to that in Burundi?
Make the answer very short. 4.3. What is the ratio of the Aid flow from UN agencies (US$) of 2010 in Sub-Saharan Africa (all income levels) to that in Burundi?
Provide a short and direct response. 7.27. What is the ratio of the Aid flow from UN agencies (US$) in 2007 in Sub-Saharan Africa (developing only) to that in Burundi?
Offer a terse response. 2.54. What is the ratio of the Aid flow from UN agencies (US$) in 2008 in Sub-Saharan Africa (developing only) to that in Burundi?
Give a very brief answer. 2.44. What is the ratio of the Aid flow from UN agencies (US$) of 2009 in Sub-Saharan Africa (developing only) to that in Burundi?
Give a very brief answer. 4.3. What is the ratio of the Aid flow from UN agencies (US$) in 2010 in Sub-Saharan Africa (developing only) to that in Burundi?
Give a very brief answer. 7.27. What is the difference between the highest and the second highest Aid flow from UN agencies (US$) in 2010?
Ensure brevity in your answer.  2.32e+06. What is the difference between the highest and the lowest Aid flow from UN agencies (US$) of 2007?
Provide a short and direct response. 9.49e+06. What is the difference between the highest and the lowest Aid flow from UN agencies (US$) of 2008?
Provide a succinct answer. 3.05e+07. What is the difference between the highest and the lowest Aid flow from UN agencies (US$) of 2009?
Offer a very short reply. 3.62e+07. What is the difference between the highest and the lowest Aid flow from UN agencies (US$) of 2010?
Provide a short and direct response. 4.30e+07. 